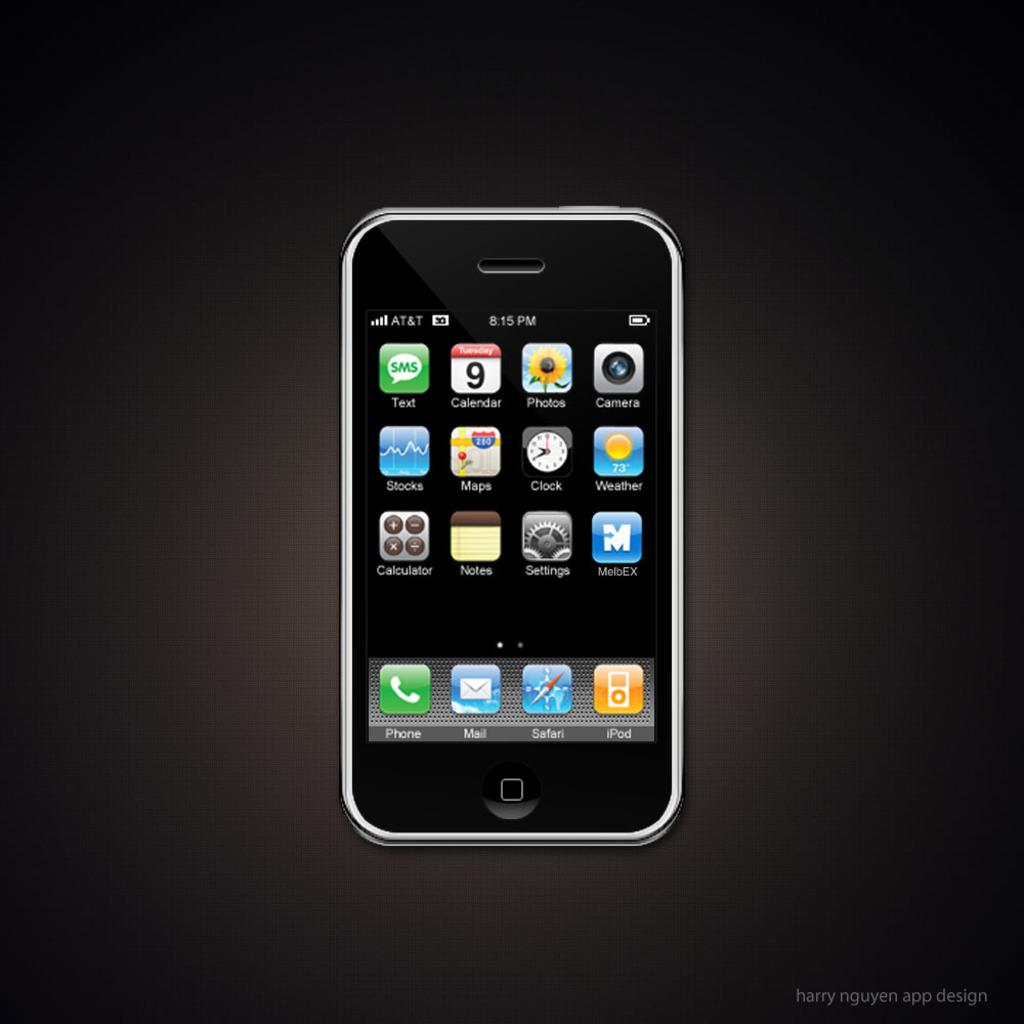<image>
Summarize the visual content of the image. A cell phone that is connected to the AT&T network. 